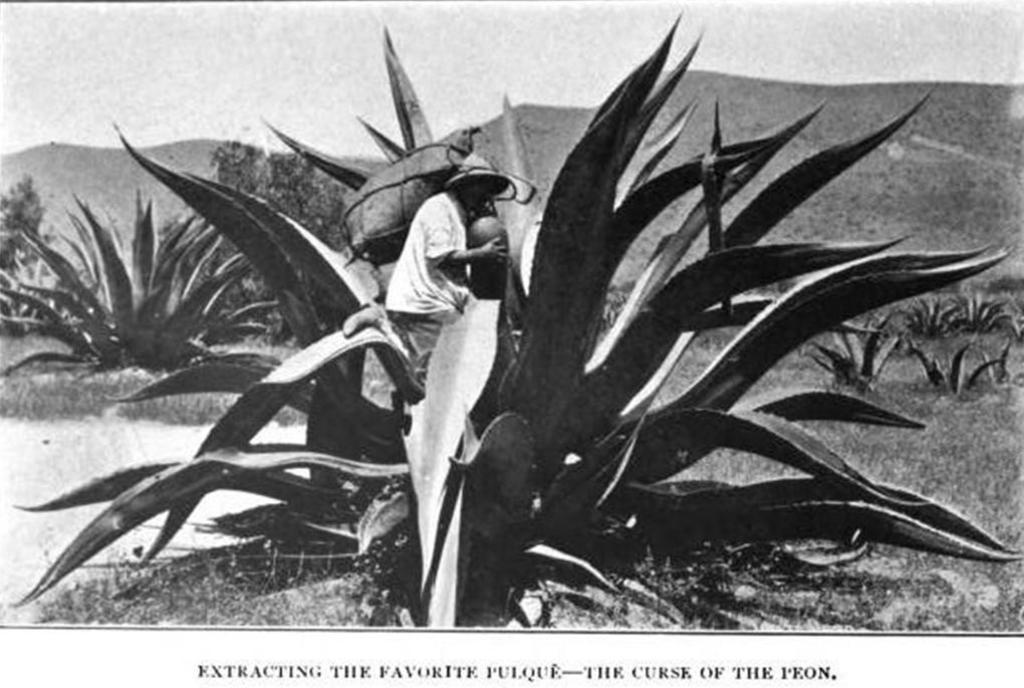Please provide a concise description of this image. In this image we can see plants. On the plant there is a person wearing hat is standing. In the back there are hills and there is sky. And this is a black and white image. 